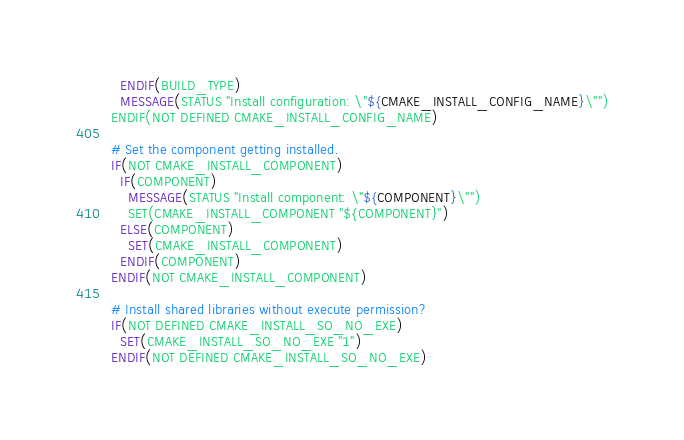<code> <loc_0><loc_0><loc_500><loc_500><_CMake_>  ENDIF(BUILD_TYPE)
  MESSAGE(STATUS "Install configuration: \"${CMAKE_INSTALL_CONFIG_NAME}\"")
ENDIF(NOT DEFINED CMAKE_INSTALL_CONFIG_NAME)

# Set the component getting installed.
IF(NOT CMAKE_INSTALL_COMPONENT)
  IF(COMPONENT)
    MESSAGE(STATUS "Install component: \"${COMPONENT}\"")
    SET(CMAKE_INSTALL_COMPONENT "${COMPONENT}")
  ELSE(COMPONENT)
    SET(CMAKE_INSTALL_COMPONENT)
  ENDIF(COMPONENT)
ENDIF(NOT CMAKE_INSTALL_COMPONENT)

# Install shared libraries without execute permission?
IF(NOT DEFINED CMAKE_INSTALL_SO_NO_EXE)
  SET(CMAKE_INSTALL_SO_NO_EXE "1")
ENDIF(NOT DEFINED CMAKE_INSTALL_SO_NO_EXE)

</code> 